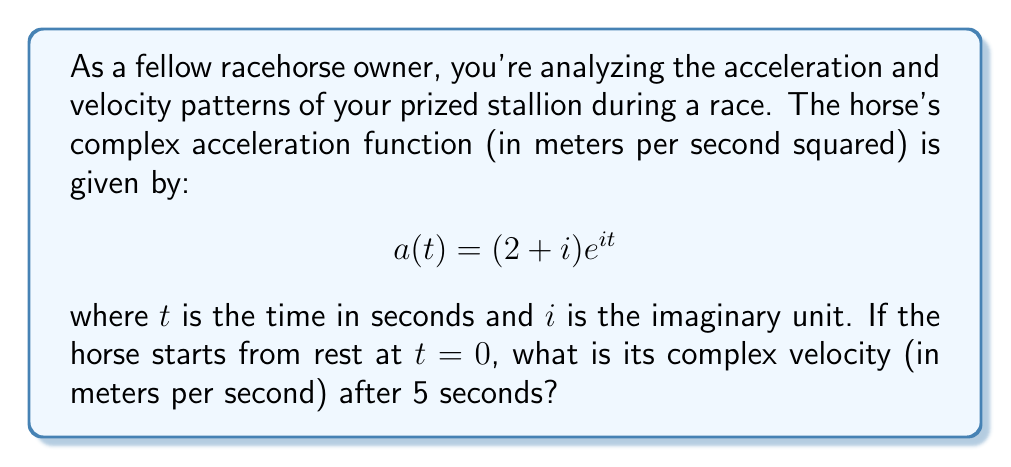Provide a solution to this math problem. To solve this problem, we need to integrate the acceleration function to find the velocity function, and then evaluate it at $t=5$. Let's break it down step-by-step:

1) The velocity function $v(t)$ is the integral of the acceleration function $a(t)$:

   $$v(t) = \int a(t) dt$$

2) We need to integrate $(2 + i) e^{it}$:

   $$v(t) = \int (2 + i) e^{it} dt$$

3) We can use the fact that $\int e^{ax} dx = \frac{1}{a}e^{ax} + C$:

   $$v(t) = (2 + i) \cdot \frac{1}{i}e^{it} + C$$

4) Simplify:

   $$v(t) = (2 + i) \cdot (-i)e^{it} + C$$
   $$v(t) = (-2i + 1)e^{it} + C$$

5) To find $C$, we use the initial condition that the horse starts from rest, so $v(0) = 0$:

   $$0 = (-2i + 1)e^{i\cdot0} + C$$
   $$0 = -2i + 1 + C$$
   $$C = 2i - 1$$

6) Therefore, the velocity function is:

   $$v(t) = (-2i + 1)e^{it} + (2i - 1)$$

7) Now, we evaluate this at $t=5$:

   $$v(5) = (-2i + 1)e^{5i} + (2i - 1)$$

8) Using Euler's formula, $e^{ix} = \cos x + i\sin x$:

   $$v(5) = (-2i + 1)(\cos 5 + i\sin 5) + (2i - 1)$$

9) Expand:

   $$v(5) = (-2i + 1)(\cos 5 + i\sin 5) + 2i - 1$$
   $$v(5) = (-2i\cos 5 + \cos 5 - 2\sin 5 + i\sin 5) + 2i - 1$$

10) Collect real and imaginary parts:

    $$v(5) = (\cos 5 - 2\sin 5 - 1) + i(-2\cos 5 + \sin 5 + 2)$$
Answer: The complex velocity after 5 seconds is:

$$v(5) = (\cos 5 - 2\sin 5 - 1) + i(-2\cos 5 + \sin 5 + 2)$$ m/s 